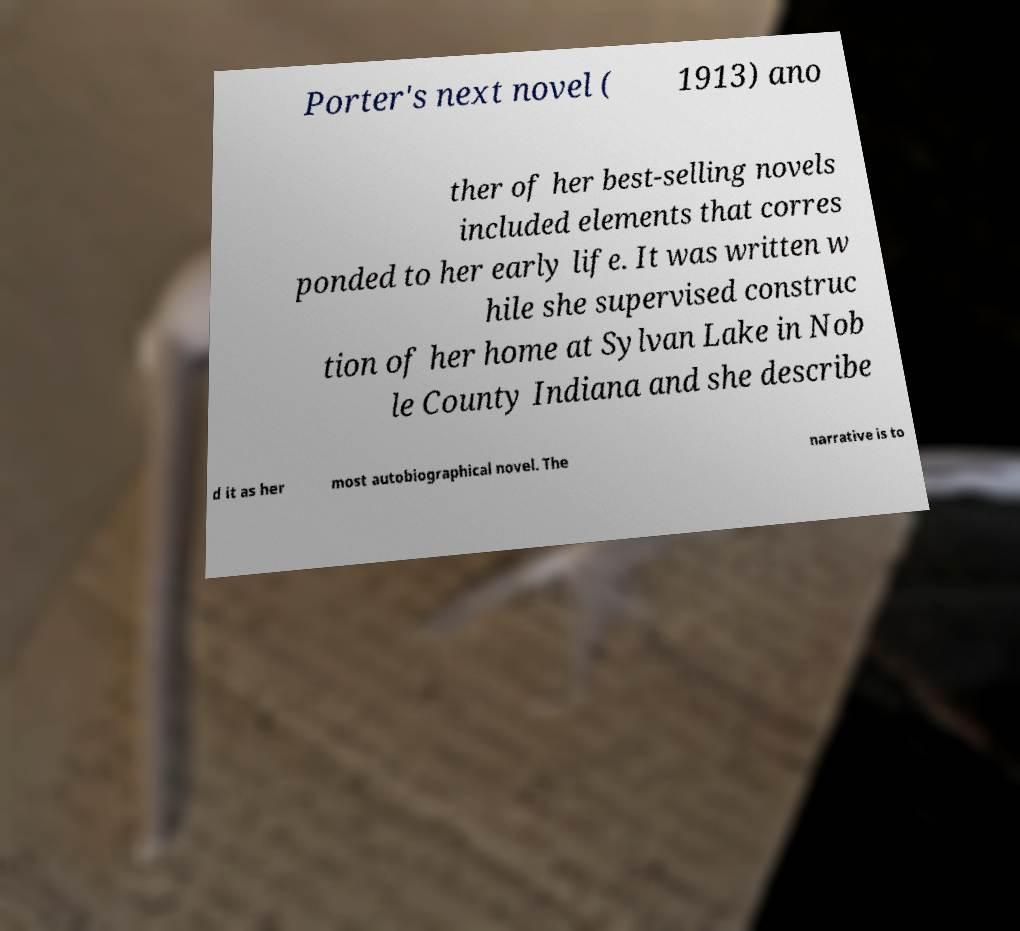Could you extract and type out the text from this image? Porter's next novel ( 1913) ano ther of her best-selling novels included elements that corres ponded to her early life. It was written w hile she supervised construc tion of her home at Sylvan Lake in Nob le County Indiana and she describe d it as her most autobiographical novel. The narrative is to 